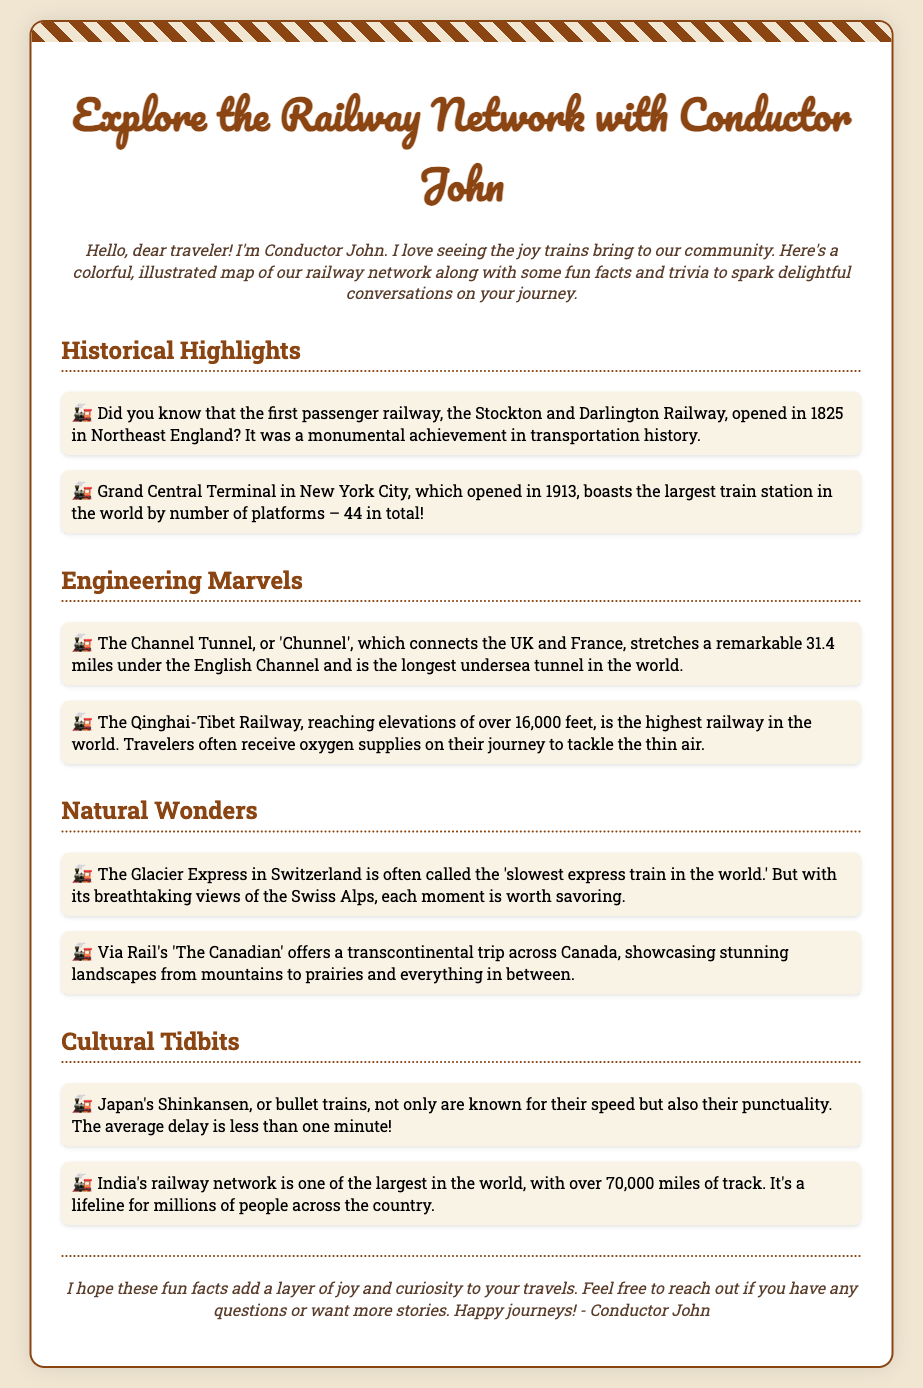What year did the Stockton and Darlington Railway open? The document states that the Stockton and Darlington Railway opened in 1825.
Answer: 1825 How many platforms does Grand Central Terminal have? According to the document, Grand Central Terminal has 44 platforms.
Answer: 44 What is the length of the Channel Tunnel? The document mentions that the Channel Tunnel stretches 31.4 miles.
Answer: 31.4 miles What is the highest railway in the world? The document identifies the Qinghai-Tibet Railway as the highest railway in the world.
Answer: Qinghai-Tibet Railway Which train is called the 'slowest express train in the world'? The document refers to the Glacier Express in Switzerland as the 'slowest express train in the world.'
Answer: Glacier Express How punctual are Japan's Shinkansen trains? The document states that the average delay for Shinkansen trains is less than one minute.
Answer: Less than one minute How many miles of track does India's railway network cover? The document indicates that India's railway network has over 70,000 miles of track.
Answer: Over 70,000 miles Who is the author of the envelope? The document mentions that Conductor John is the author of the envelope.
Answer: Conductor John What type of information can travelers find in this envelope? The document presents fun facts and trivia about the railway network.
Answer: Fun facts and trivia 